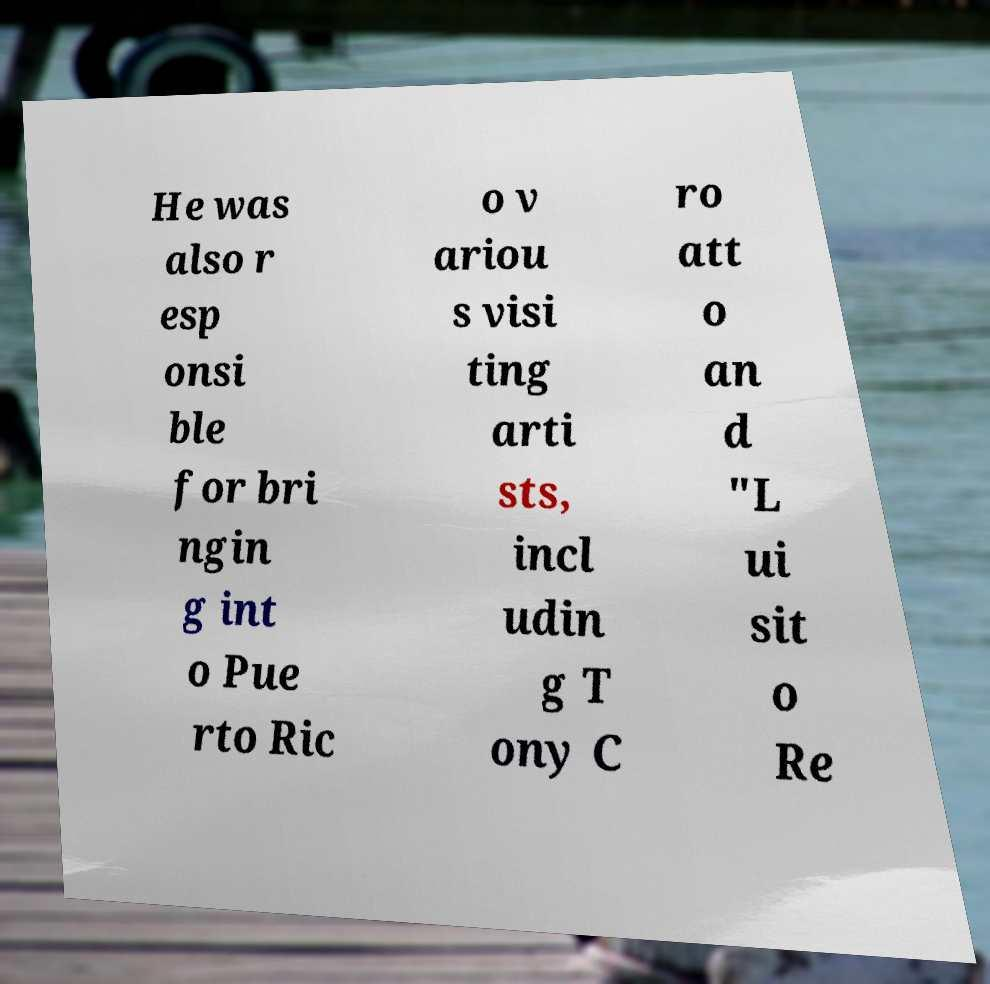There's text embedded in this image that I need extracted. Can you transcribe it verbatim? He was also r esp onsi ble for bri ngin g int o Pue rto Ric o v ariou s visi ting arti sts, incl udin g T ony C ro att o an d "L ui sit o Re 